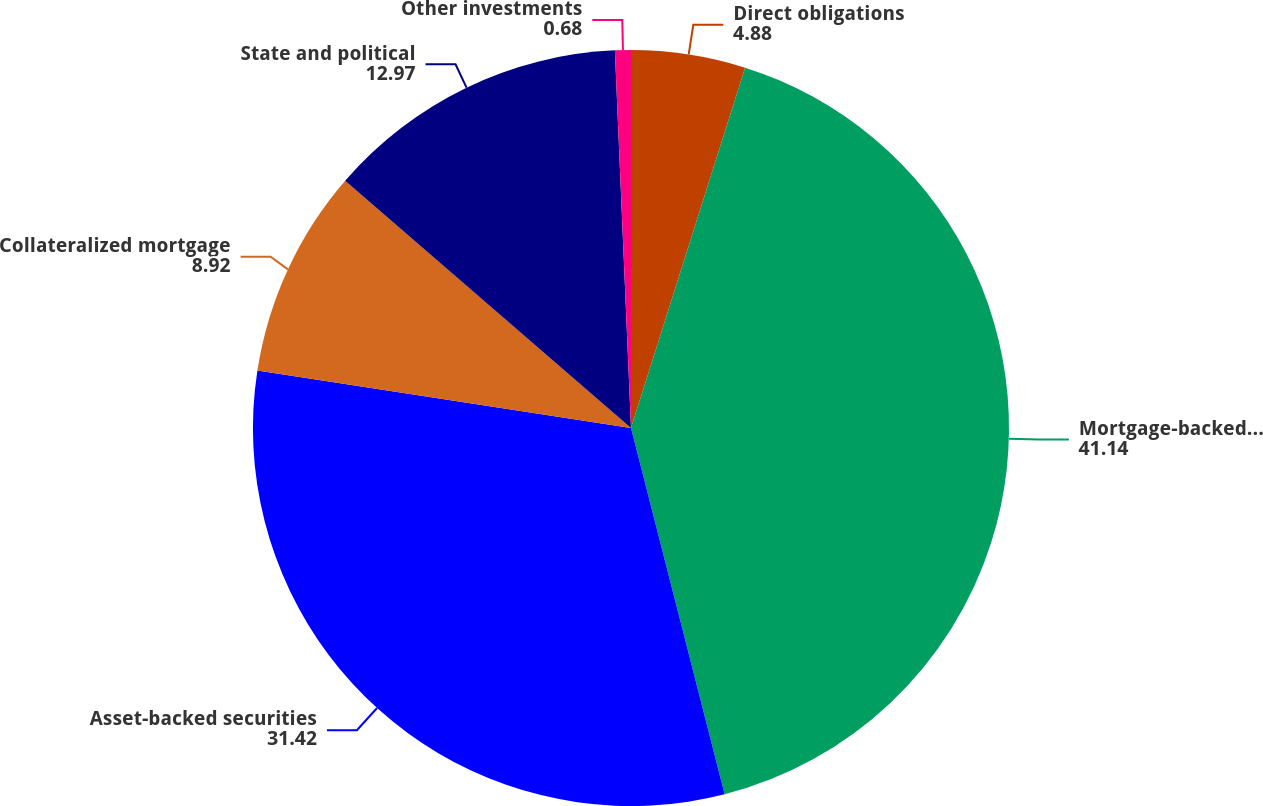<chart> <loc_0><loc_0><loc_500><loc_500><pie_chart><fcel>Direct obligations<fcel>Mortgage-backed securities<fcel>Asset-backed securities<fcel>Collateralized mortgage<fcel>State and political<fcel>Other investments<nl><fcel>4.88%<fcel>41.14%<fcel>31.42%<fcel>8.92%<fcel>12.97%<fcel>0.68%<nl></chart> 